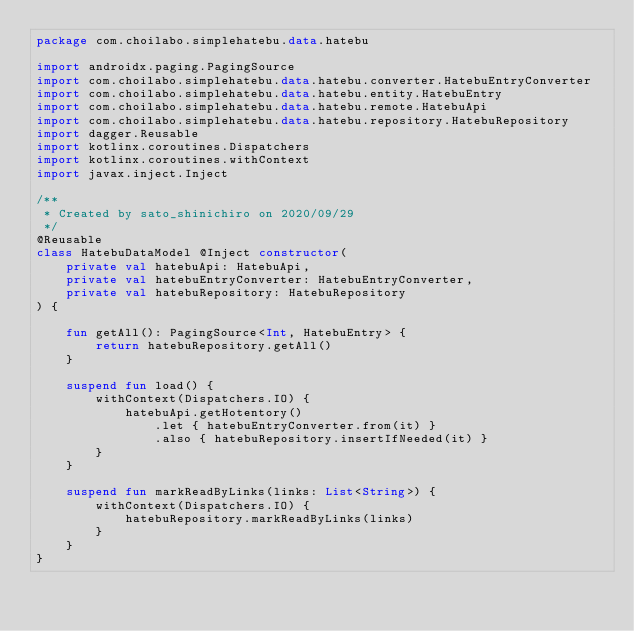Convert code to text. <code><loc_0><loc_0><loc_500><loc_500><_Kotlin_>package com.choilabo.simplehatebu.data.hatebu

import androidx.paging.PagingSource
import com.choilabo.simplehatebu.data.hatebu.converter.HatebuEntryConverter
import com.choilabo.simplehatebu.data.hatebu.entity.HatebuEntry
import com.choilabo.simplehatebu.data.hatebu.remote.HatebuApi
import com.choilabo.simplehatebu.data.hatebu.repository.HatebuRepository
import dagger.Reusable
import kotlinx.coroutines.Dispatchers
import kotlinx.coroutines.withContext
import javax.inject.Inject

/**
 * Created by sato_shinichiro on 2020/09/29
 */
@Reusable
class HatebuDataModel @Inject constructor(
    private val hatebuApi: HatebuApi,
    private val hatebuEntryConverter: HatebuEntryConverter,
    private val hatebuRepository: HatebuRepository
) {

    fun getAll(): PagingSource<Int, HatebuEntry> {
        return hatebuRepository.getAll()
    }

    suspend fun load() {
        withContext(Dispatchers.IO) {
            hatebuApi.getHotentory()
                .let { hatebuEntryConverter.from(it) }
                .also { hatebuRepository.insertIfNeeded(it) }
        }
    }

    suspend fun markReadByLinks(links: List<String>) {
        withContext(Dispatchers.IO) {
            hatebuRepository.markReadByLinks(links)
        }
    }
}</code> 